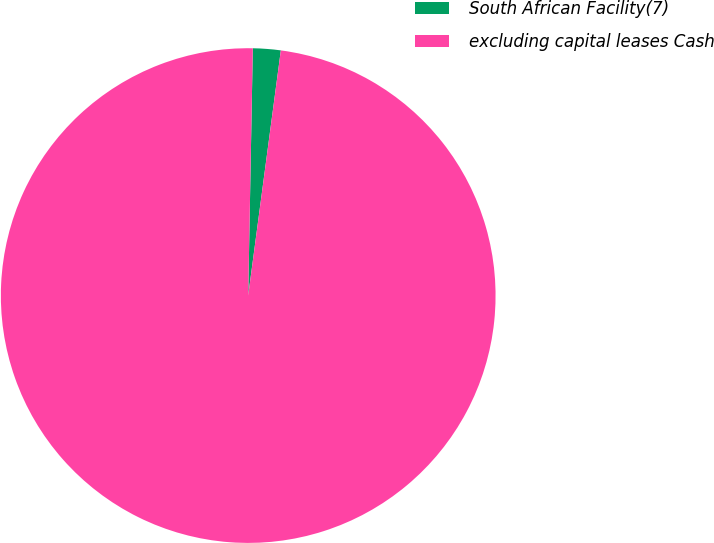Convert chart. <chart><loc_0><loc_0><loc_500><loc_500><pie_chart><fcel>South African Facility(7)<fcel>excluding capital leases Cash<nl><fcel>1.81%<fcel>98.19%<nl></chart> 